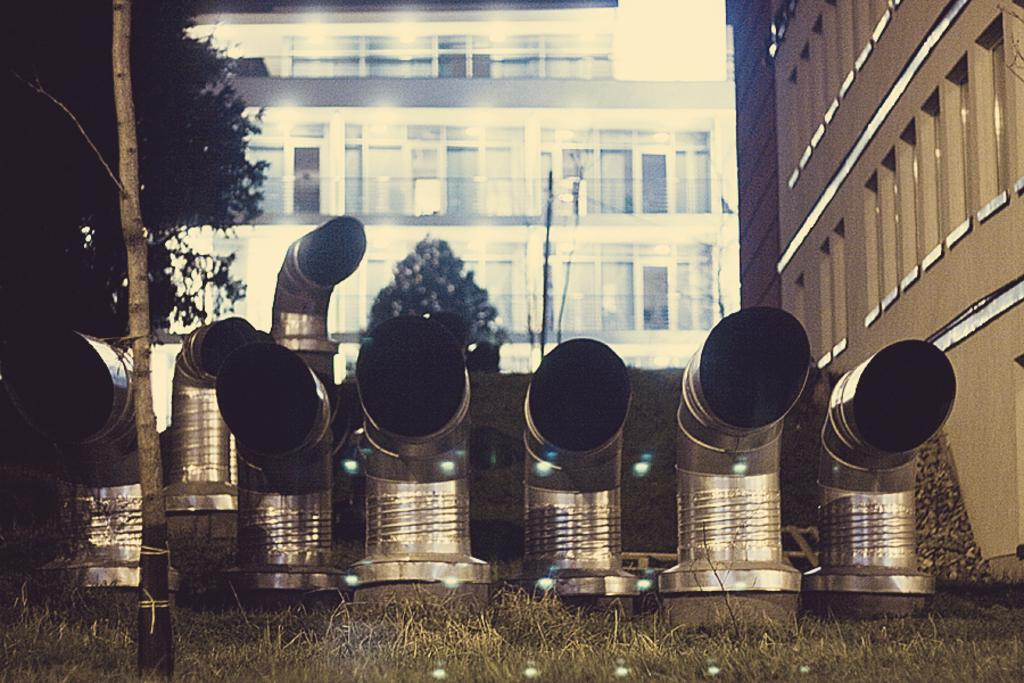What type of structures can be seen in the image? There are exhaust pipes, buildings, and trees visible in the image. What type of vegetation is present in the image? There is green grass visible in the image. How many blades are attached to the trees in the image? There are no blades attached to the trees in the image; trees typically have leaves or needles. Can you describe the women in the image? There are no women present in the image. 